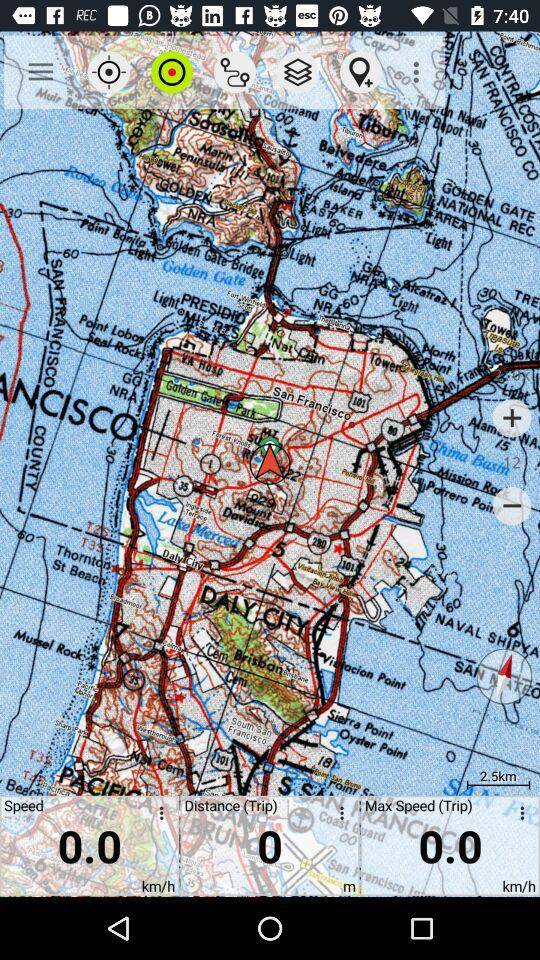What is the current speed? The current speed is 0.0 km/h. 